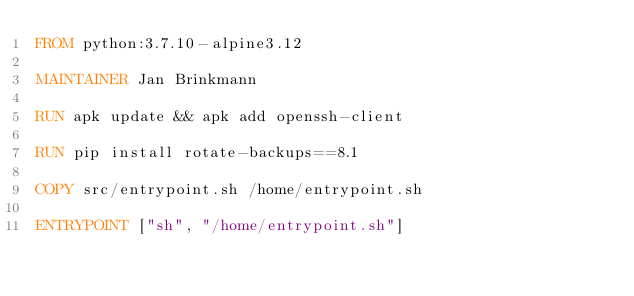Convert code to text. <code><loc_0><loc_0><loc_500><loc_500><_Dockerfile_>FROM python:3.7.10-alpine3.12

MAINTAINER Jan Brinkmann

RUN apk update && apk add openssh-client

RUN pip install rotate-backups==8.1

COPY src/entrypoint.sh /home/entrypoint.sh

ENTRYPOINT ["sh", "/home/entrypoint.sh"]
</code> 